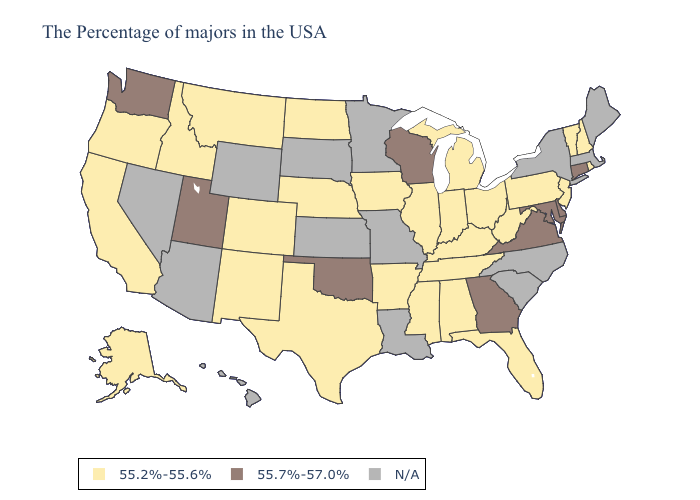Does Connecticut have the lowest value in the USA?
Keep it brief. No. Does Virginia have the lowest value in the USA?
Write a very short answer. No. Name the states that have a value in the range 55.7%-57.0%?
Give a very brief answer. Connecticut, Delaware, Maryland, Virginia, Georgia, Wisconsin, Oklahoma, Utah, Washington. What is the value of Florida?
Write a very short answer. 55.2%-55.6%. Name the states that have a value in the range N/A?
Give a very brief answer. Maine, Massachusetts, New York, North Carolina, South Carolina, Louisiana, Missouri, Minnesota, Kansas, South Dakota, Wyoming, Arizona, Nevada, Hawaii. Is the legend a continuous bar?
Answer briefly. No. What is the value of Nevada?
Give a very brief answer. N/A. Does Oklahoma have the lowest value in the South?
Be succinct. No. How many symbols are there in the legend?
Answer briefly. 3. What is the value of Arizona?
Give a very brief answer. N/A. Does California have the highest value in the West?
Be succinct. No. Which states have the lowest value in the Northeast?
Be succinct. Rhode Island, New Hampshire, Vermont, New Jersey, Pennsylvania. Does Utah have the highest value in the USA?
Short answer required. Yes. 